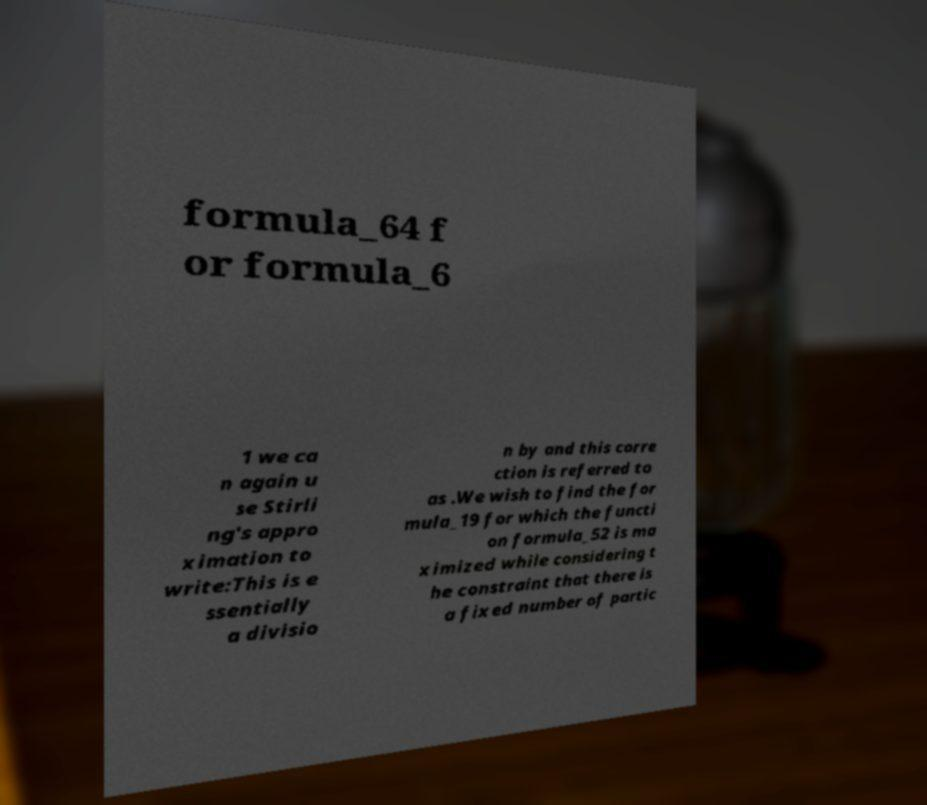Can you read and provide the text displayed in the image?This photo seems to have some interesting text. Can you extract and type it out for me? formula_64 f or formula_6 1 we ca n again u se Stirli ng's appro ximation to write:This is e ssentially a divisio n by and this corre ction is referred to as .We wish to find the for mula_19 for which the functi on formula_52 is ma ximized while considering t he constraint that there is a fixed number of partic 